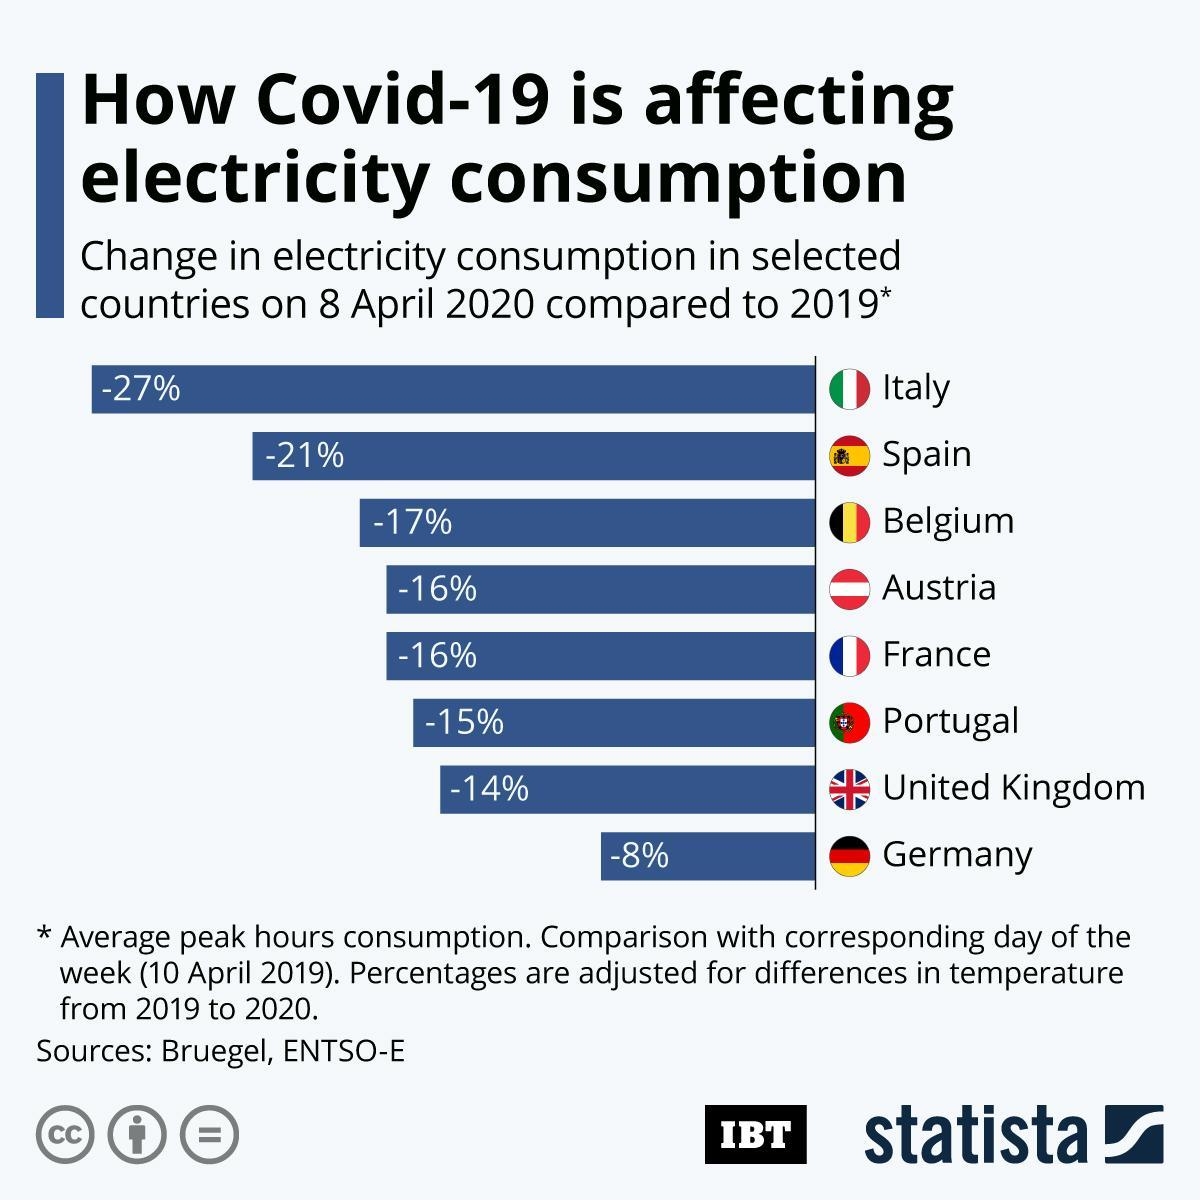Outline some significant characteristics in this image. On 8 April 2020, Spain had the second highest percentage change in electricity consumption compared to 2019 among the selected countries. On April 8, 2020, the electricity consumption in the UK was 14% lower compared to the same date in 2019. On 8 April 2020, the electricity consumption in Spain decreased by 21% compared to the previous year. On 8 April 2020, compared to 2019, Italy showed the highest percentage change in electricity consumption among the selected countries. On 8 April 2020, compared to 2019, Germany had the least percentage change in electricity consumption among the selected countries. 